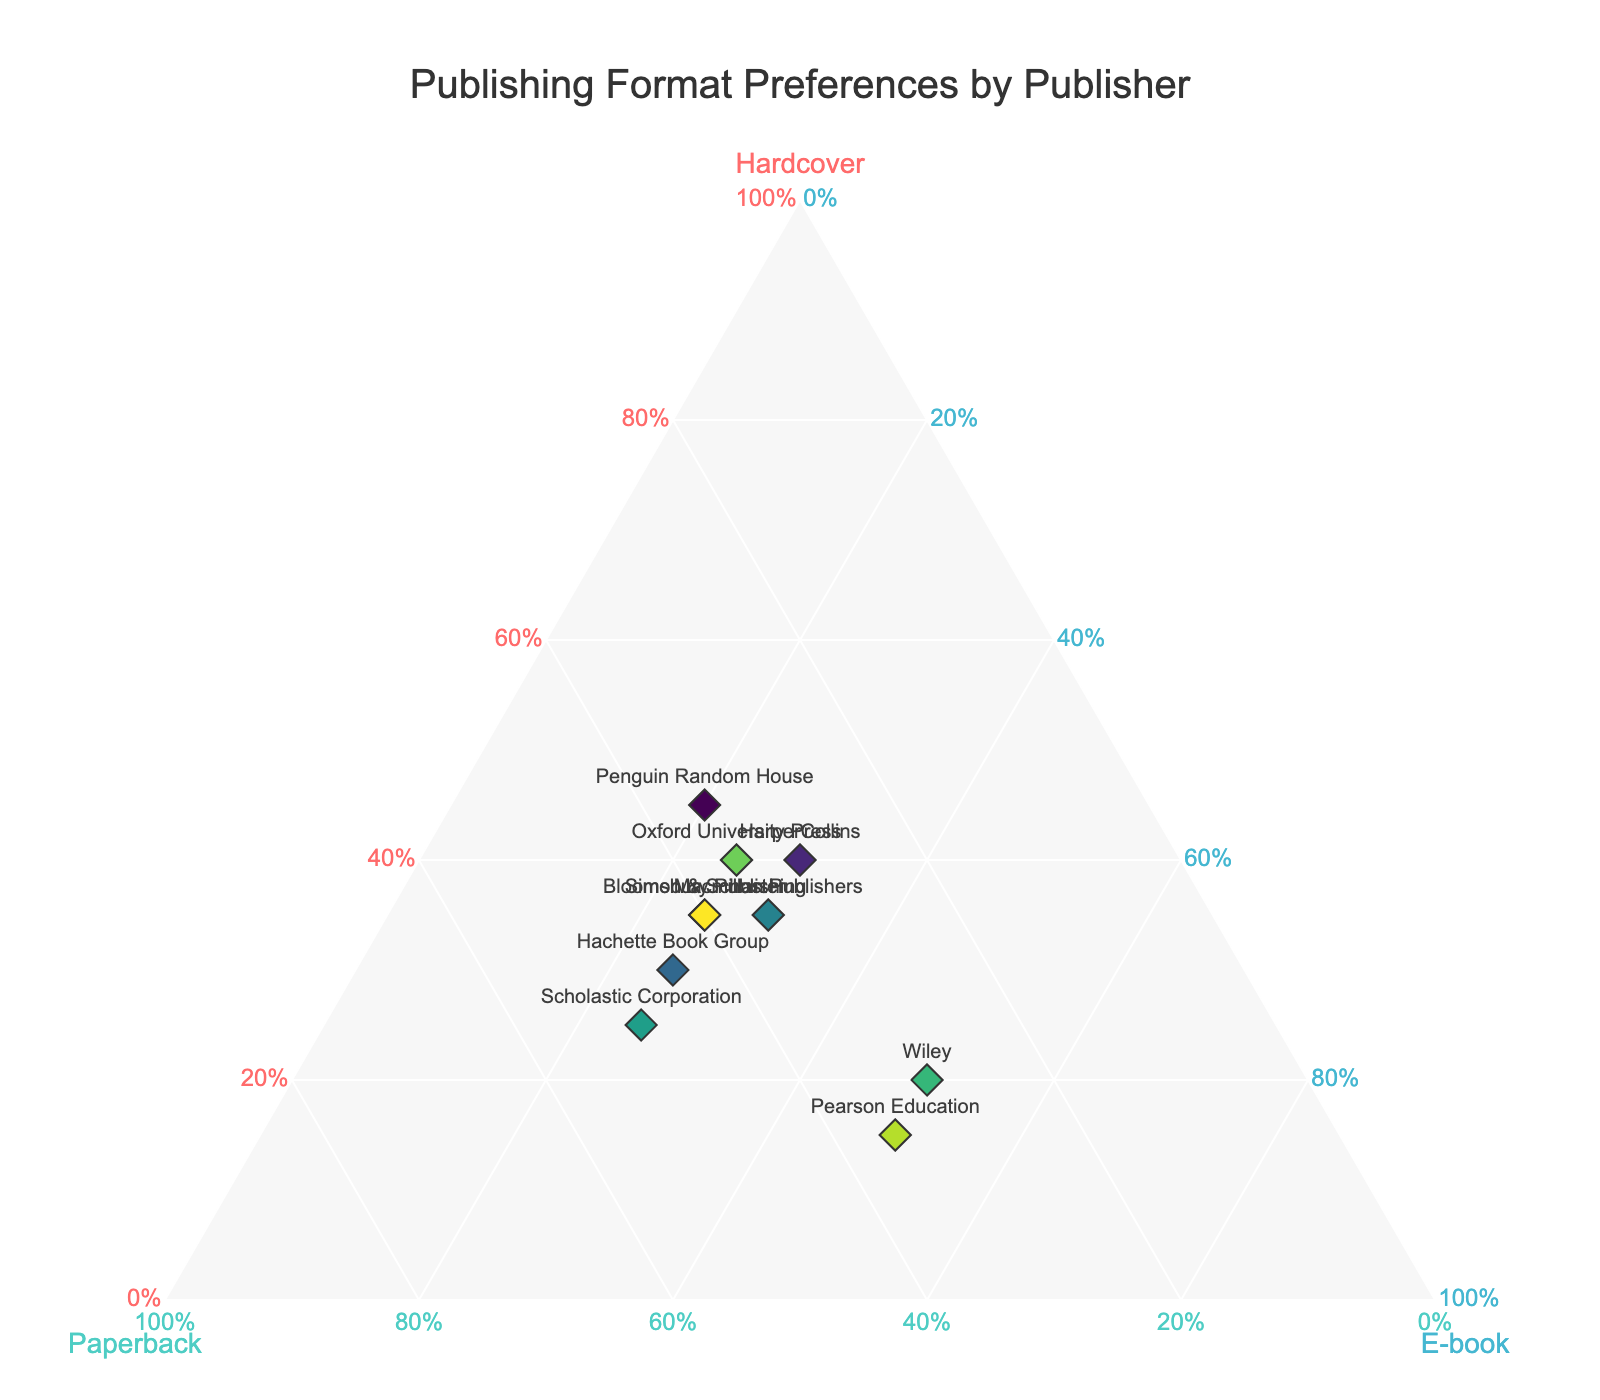What is the title of the plot? The title of the plot is displayed at the top of the figure.
Answer: Publishing Format Preferences by Publisher How many publishers are represented in the plot? Count the total number of points in the plot. Each point represents a different publisher.
Answer: 10 Which publisher has the highest preference for e-books? Identify the point that is located closest to the E-book axis (denoted by higher 'c' values).
Answer: Wiley What percentage of Penguin Random House’s preference is for paperbacks? Locate the point labeled "Penguin Random House" and read the value next to the Paperback axis.
Answer: 35% Which publishers have an equal preference for paperbacks and e-books? Look for points where the values for the paperback and e-book preferences are equal.
Answer: Macmillan Publishers, Hachette Book Group (where paperback=35%, ebook=25%) Which publisher has the highest preference for hardcover? Find the point closest to the Hardcover axis (denoted by higher 'a' values).
Answer: Penguin Random House How does Pearson Education's preference for hardcover compare to Scholastic Corporation's preference for the same format? Compare the hardcover preference values for Pearson Education and Scholastic Corporation from the plot.
Answer: Pearson Education has a lower preference (15%) compared to Scholastic Corporation (25%) What is the average preference value for hardcovers across all publishers? Sum the hardcover preference values for all publishers and divide by the number of publishers. (0.45+0.40+0.35+0.30+0.35+0.25+0.20+0.40+0.15+0.35)/10 = 3.2/10 = 0.32
Answer: 32% Which publishers have a paperback preference above 40%? Identify points whose paperback values exceed 40%.
Answer: Simon & Schuster, Hachette Book Group, Scholastic Corporation, Bloomsbury Publishing How does the combined e-book preference of HarperCollins and Oxford University Press compare to Wiley's e-book preference? Add the e-book preferences of HarperCollins and Oxford University Press and then compare with Wiley's e-book preference. (30% + 25%) = 55% which is greater than Wiley's 50%.
Answer: Combined preference is greater 